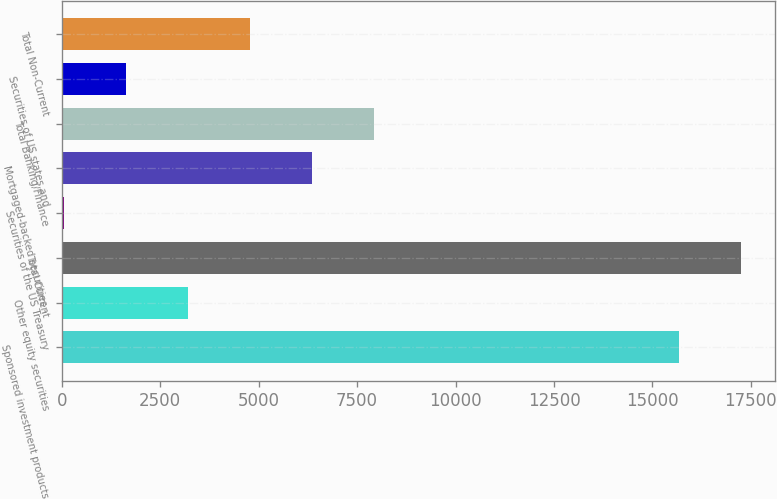Convert chart to OTSL. <chart><loc_0><loc_0><loc_500><loc_500><bar_chart><fcel>Sponsored investment products<fcel>Other equity securities<fcel>Total Current<fcel>Securities of the US Treasury<fcel>Mortgaged-backed securities -<fcel>Total Banking/Finance<fcel>Securities of US states and<fcel>Total Non-Current<nl><fcel>15676<fcel>3212.6<fcel>17249.3<fcel>66<fcel>6359.2<fcel>7932.5<fcel>1639.3<fcel>4785.9<nl></chart> 